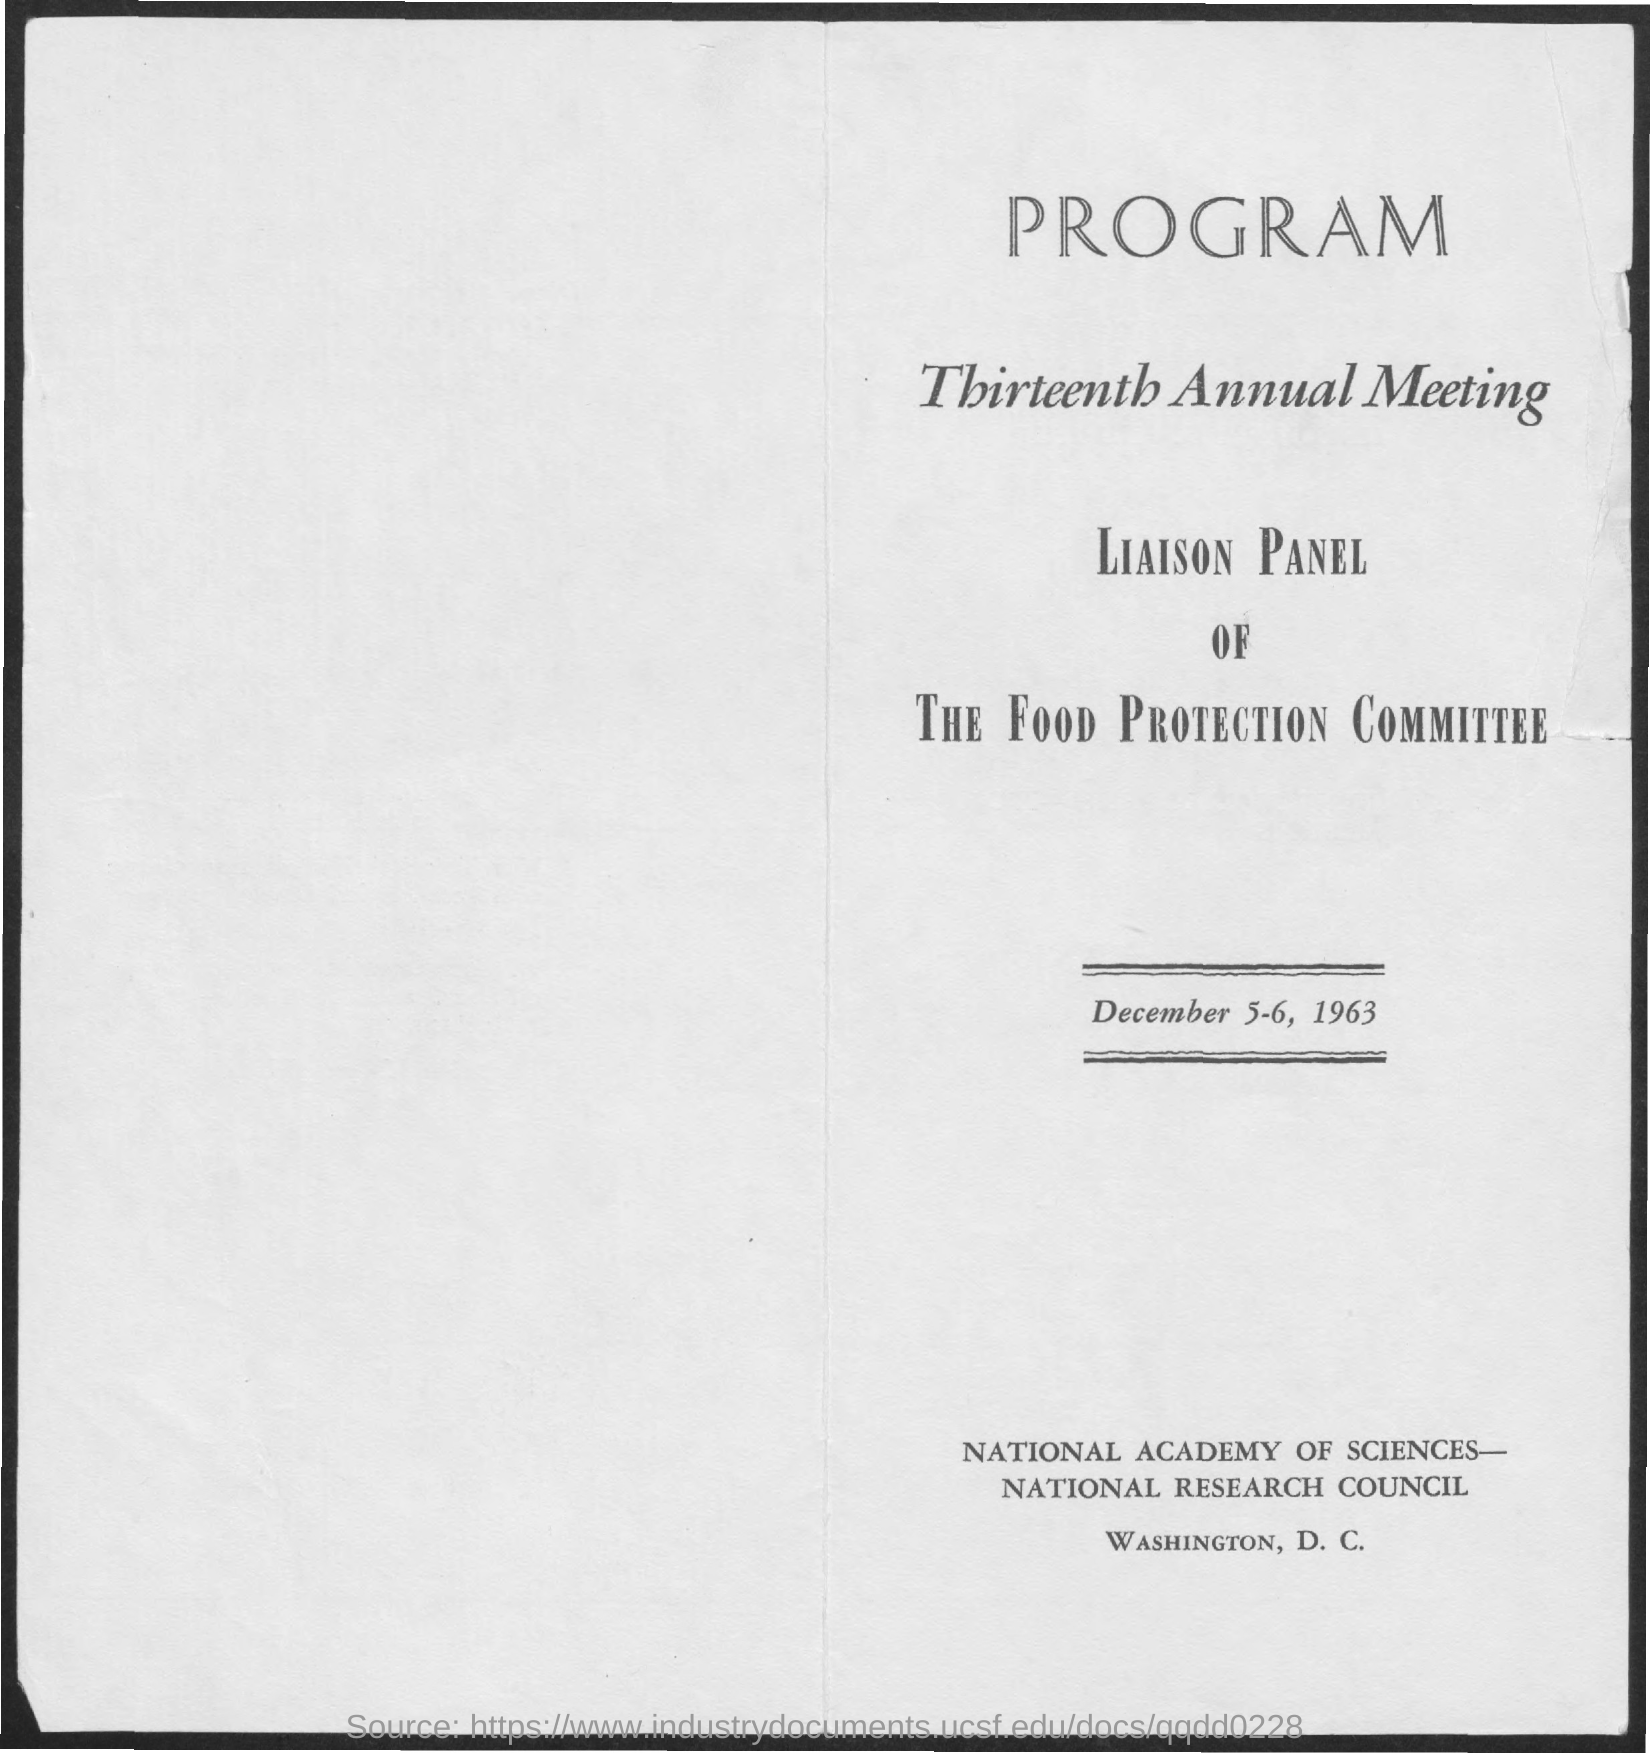What is the second title in the document?
Offer a very short reply. Thirteenth annual meeting. 